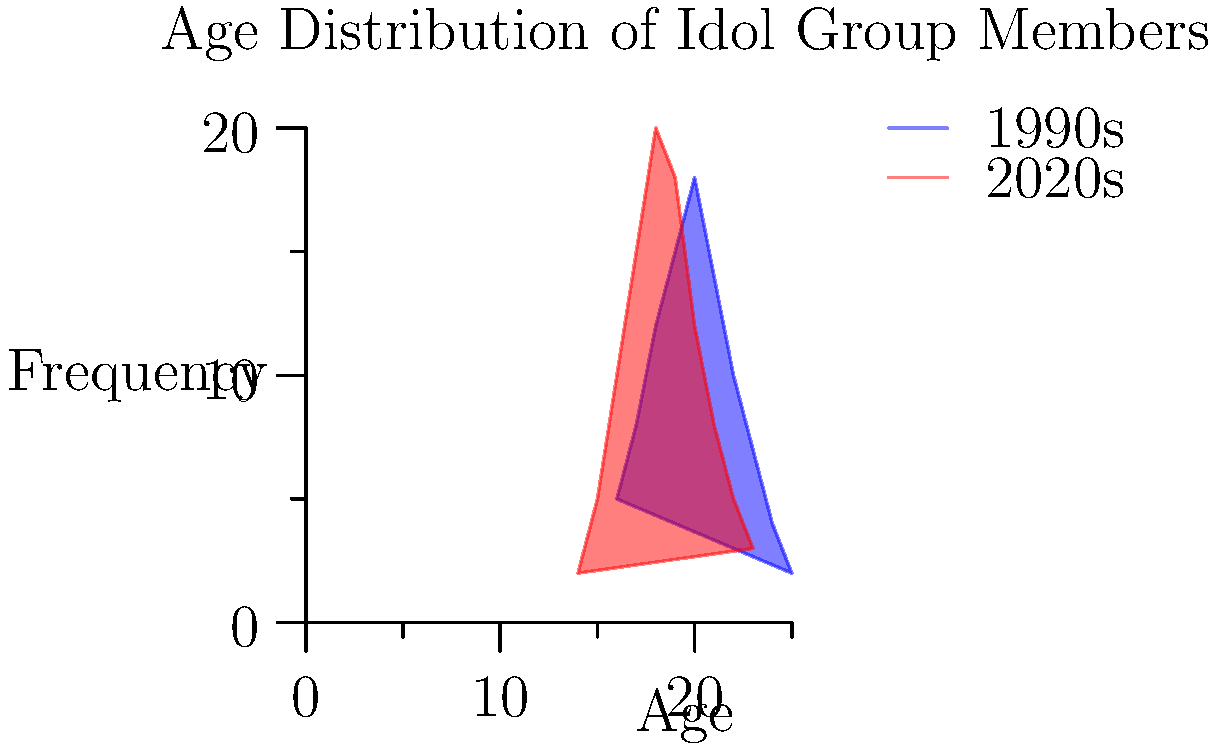Based on the overlapping histograms comparing the age distribution of idol group members in the 1990s vs 2020s, what is the most significant change in the industry that can be inferred? To answer this question, we need to analyze the histograms carefully:

1. Age range:
   - 1990s: The distribution spans from 16 to 25 years old.
   - 2020s: The distribution spans from 14 to 23 years old.

2. Peak frequency:
   - 1990s: The peak is around 20 years old.
   - 2020s: The peak is around 18 years old.

3. Distribution shape:
   - 1990s: More evenly distributed, with a gradual increase and decrease.
   - 2020s: More skewed towards younger ages, with a sharper increase and decrease.

4. Younger members:
   - 2020s show a higher frequency of members aged 14-17 compared to the 1990s.

5. Older members:
   - 1990s show a higher frequency of members aged 22-25 compared to the 2020s.

The most significant change that can be inferred from this data is the trend towards younger idol group members in the 2020s compared to the 1990s. This is evidenced by:

a) The overall shift of the distribution towards younger ages
b) The lower minimum age (14 in 2020s vs 16 in 1990s)
c) The earlier peak age (18 in 2020s vs 20 in 1990s)
d) The higher frequency of teenage members in the 2020s

This trend suggests that the idol industry has been favoring younger talents in recent years, possibly to appeal to a younger fanbase or to capitalize on the "youth" image more aggressively.
Answer: Trend towards younger idol group members in the 2020s 